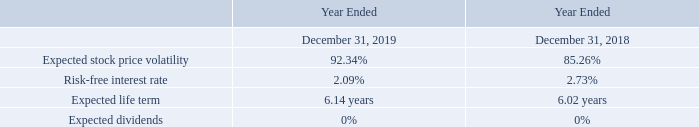The fair value of each option grant was estimated on the date of grant using the Black-Scholes option pricing model using the following weighted average assumptions:
Based on the Black-Scholes option pricing model, the weighted average estimated fair value of employee stock options granted was $4.63 and $2.58 per share during the years ended December 31, 2019 and 2018, respectively.
The expected life was determined using the simplified method outlined in ASC 718, “Compensation - Stock Compensation”. Expected volatility of the stock options was based upon historical data and other relevant factors. We have not provided an estimate for forfeitures because we have had nominal forfeited options and RSUs and believed that all outstanding options and RSUs at December 31, 2019, would vest.
How was the expected life determined? Using the simplified method outlined in asc 718, “compensation - stock compensation”. How was the fair value of each option grant estimated? Using the black-scholes option pricing model. What is the risk-free interest rate in 2018? 2.73%. What is the percentage change in the weighted average estimated fair value of employee stock options granted per share in 2019?
Answer scale should be: percent. (4.63-2.58)/2.58 
Answer: 79.46. What was the change in the expected life term between 2018 and 2019? 6.14 - 6.02 
Answer: 0.12. Which year has a larger risk-free interest rate? 2.73% > 2.09%
Answer: 2018. 